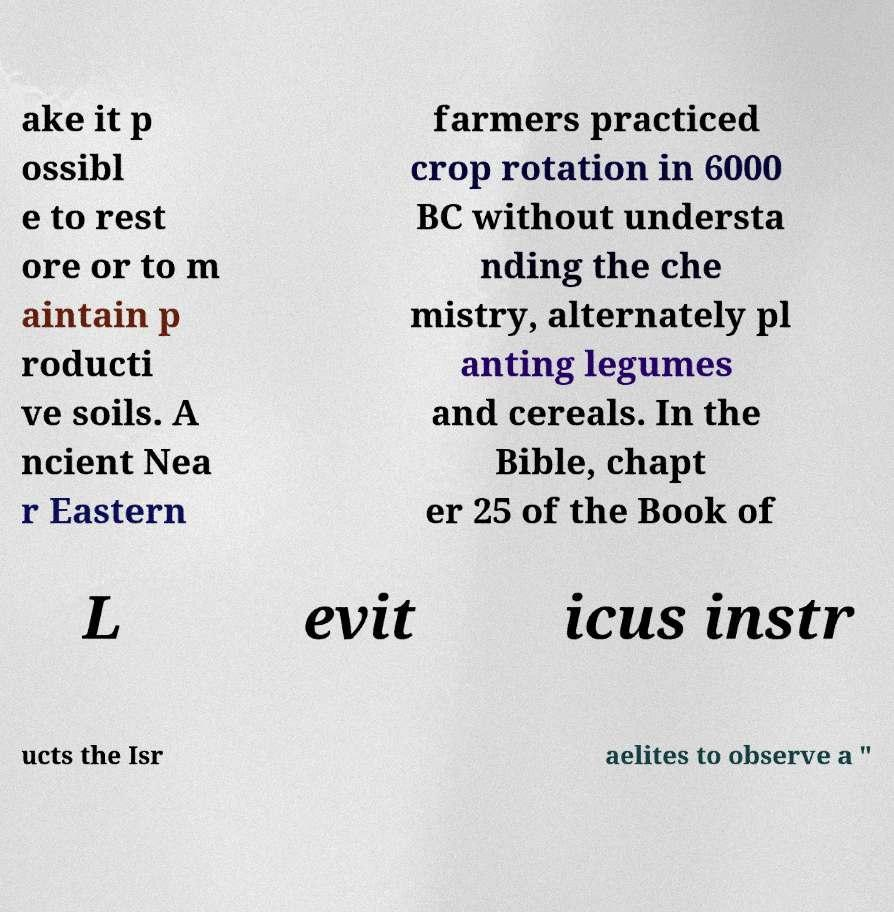Can you accurately transcribe the text from the provided image for me? ake it p ossibl e to rest ore or to m aintain p roducti ve soils. A ncient Nea r Eastern farmers practiced crop rotation in 6000 BC without understa nding the che mistry, alternately pl anting legumes and cereals. In the Bible, chapt er 25 of the Book of L evit icus instr ucts the Isr aelites to observe a " 